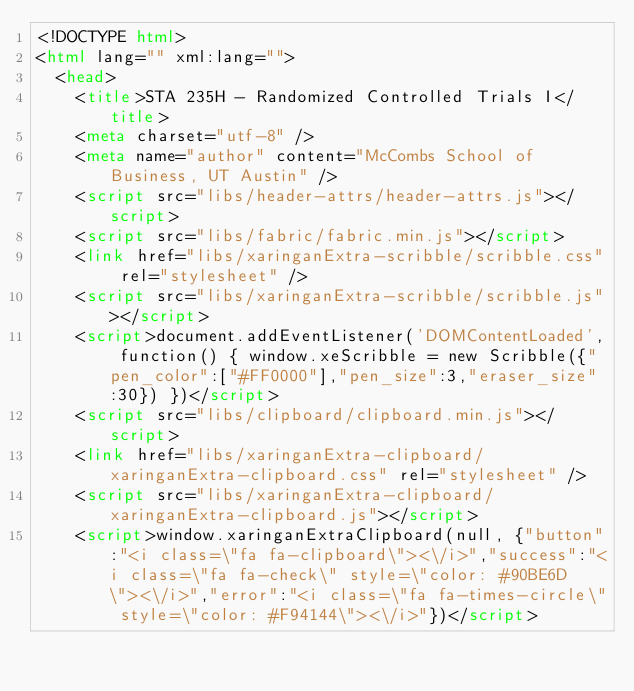<code> <loc_0><loc_0><loc_500><loc_500><_HTML_><!DOCTYPE html>
<html lang="" xml:lang="">
  <head>
    <title>STA 235H - Randomized Controlled Trials I</title>
    <meta charset="utf-8" />
    <meta name="author" content="McCombs School of Business, UT Austin" />
    <script src="libs/header-attrs/header-attrs.js"></script>
    <script src="libs/fabric/fabric.min.js"></script>
    <link href="libs/xaringanExtra-scribble/scribble.css" rel="stylesheet" />
    <script src="libs/xaringanExtra-scribble/scribble.js"></script>
    <script>document.addEventListener('DOMContentLoaded', function() { window.xeScribble = new Scribble({"pen_color":["#FF0000"],"pen_size":3,"eraser_size":30}) })</script>
    <script src="libs/clipboard/clipboard.min.js"></script>
    <link href="libs/xaringanExtra-clipboard/xaringanExtra-clipboard.css" rel="stylesheet" />
    <script src="libs/xaringanExtra-clipboard/xaringanExtra-clipboard.js"></script>
    <script>window.xaringanExtraClipboard(null, {"button":"<i class=\"fa fa-clipboard\"><\/i>","success":"<i class=\"fa fa-check\" style=\"color: #90BE6D\"><\/i>","error":"<i class=\"fa fa-times-circle\" style=\"color: #F94144\"><\/i>"})</script></code> 